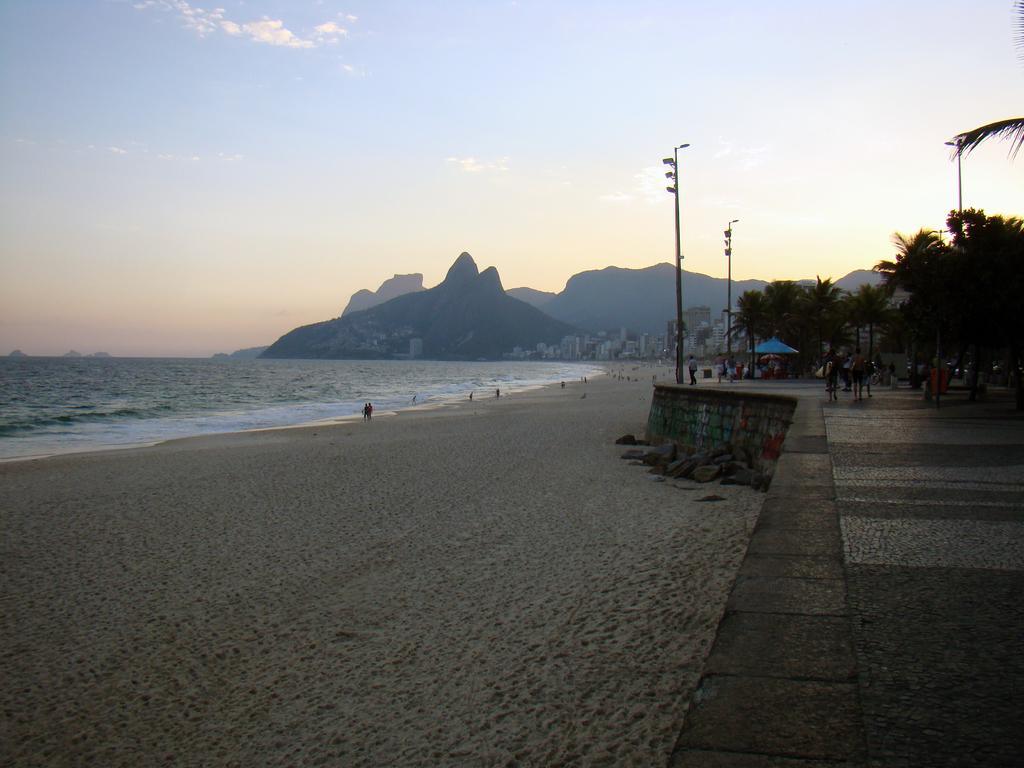How would you summarize this image in a sentence or two? In this image, we can see few mountains, trees, poles, shed, buildings, few peoples, water. At the bottom, we can see sand and platform. Top of the image, there is a sky. 